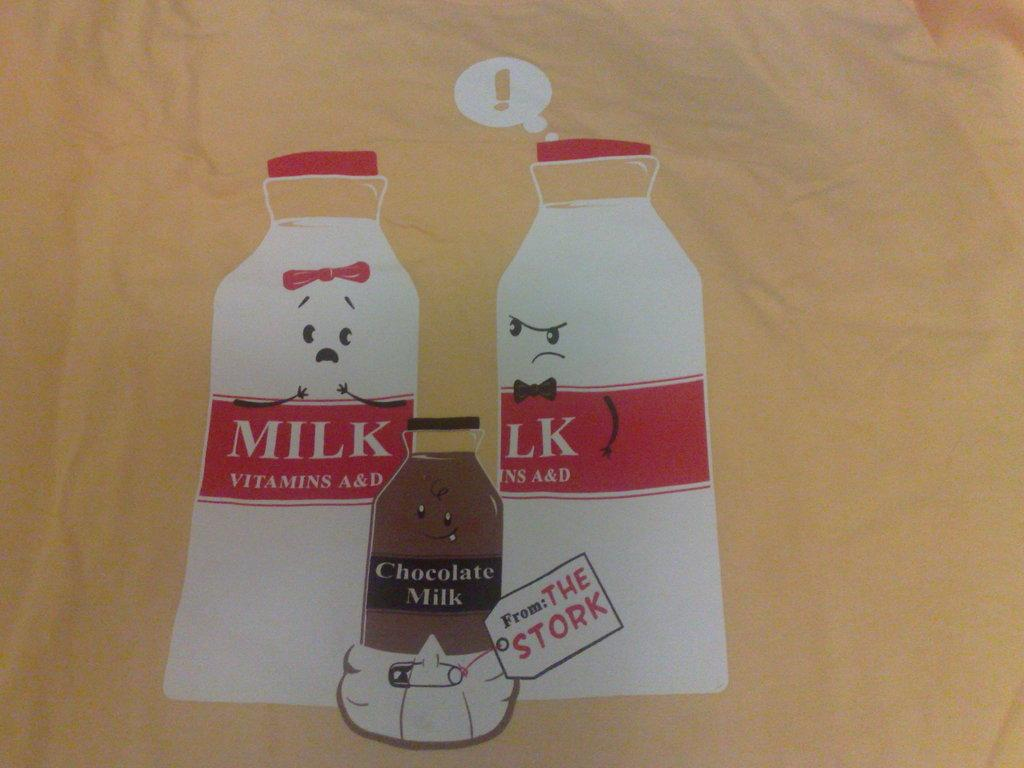How many bottles can be seen in the image? There are three bottles in the image. What is present on the bottles? There is writing on the bottles. Are there any cobwebs visible in the image? There is no mention of cobwebs in the provided facts, and therefore we cannot determine if any are present in the image. 